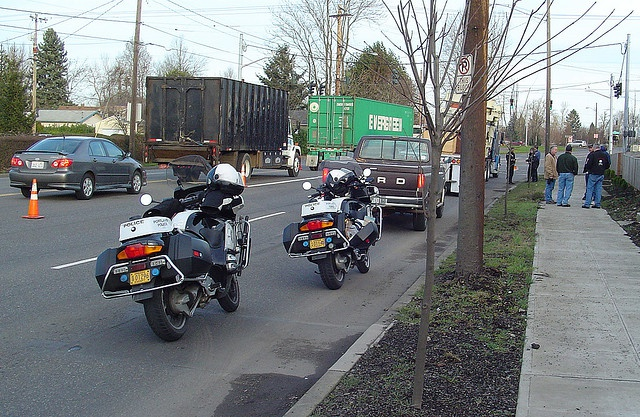Describe the objects in this image and their specific colors. I can see motorcycle in lightblue, black, gray, white, and blue tones, truck in lightblue, gray, black, and purple tones, motorcycle in white, black, gray, and darkgray tones, truck in lightblue, gray, black, darkgray, and white tones, and car in white, gray, black, and darkgray tones in this image. 